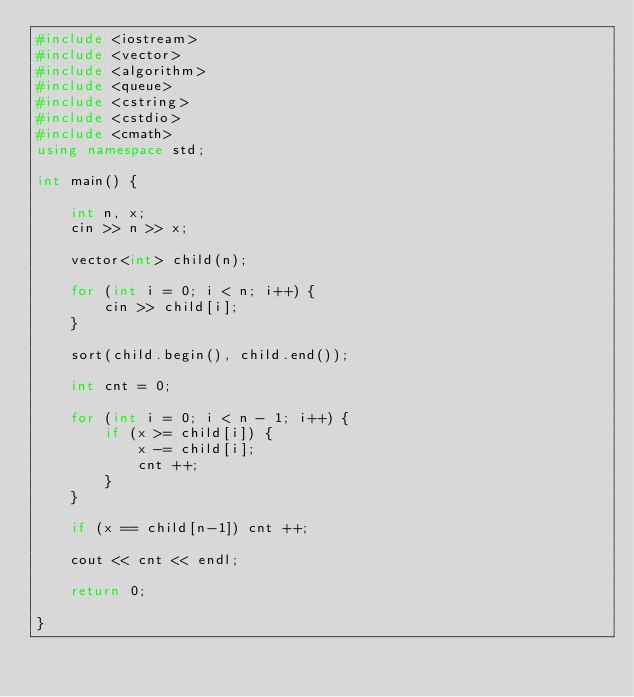Convert code to text. <code><loc_0><loc_0><loc_500><loc_500><_C++_>#include <iostream>
#include <vector>
#include <algorithm>
#include <queue>
#include <cstring>
#include <cstdio>
#include <cmath>
using namespace std;

int main() {

    int n, x;
    cin >> n >> x;

    vector<int> child(n);

    for (int i = 0; i < n; i++) {
        cin >> child[i];
    }

    sort(child.begin(), child.end());

    int cnt = 0;
    
    for (int i = 0; i < n - 1; i++) {
        if (x >= child[i]) {
            x -= child[i];
            cnt ++;
        }
    }

    if (x == child[n-1]) cnt ++; 
    
    cout << cnt << endl;

    return 0;   

}
</code> 